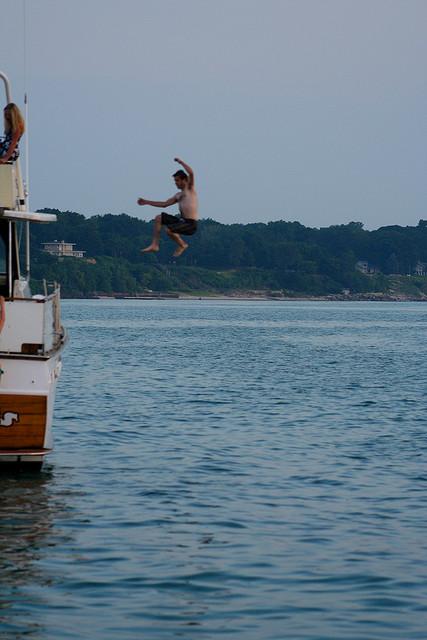What vehicle is this?
Concise answer only. Boat. Is the boy going to land in the water?
Give a very brief answer. Yes. Are the swans in the pond?
Give a very brief answer. No. Is someone jumping off a boat?
Concise answer only. Yes. Is the weather cool?
Quick response, please. No. 